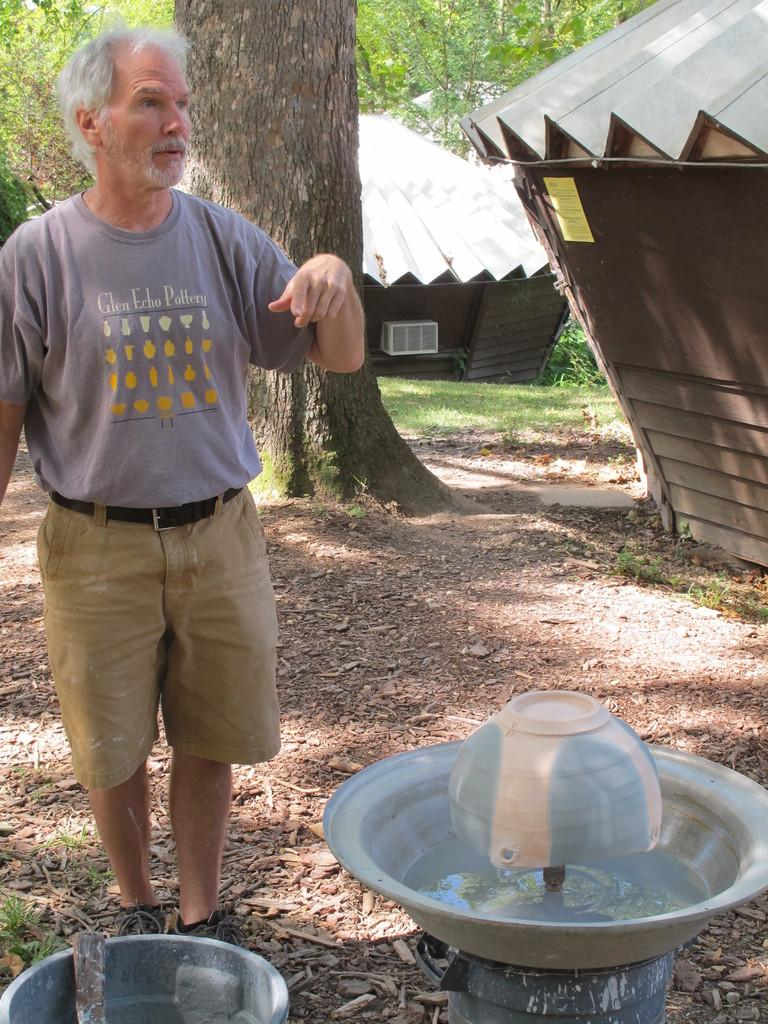<image>
Write a terse but informative summary of the picture. The man in grey is wearing a shirt from Glen Echo Pottery 